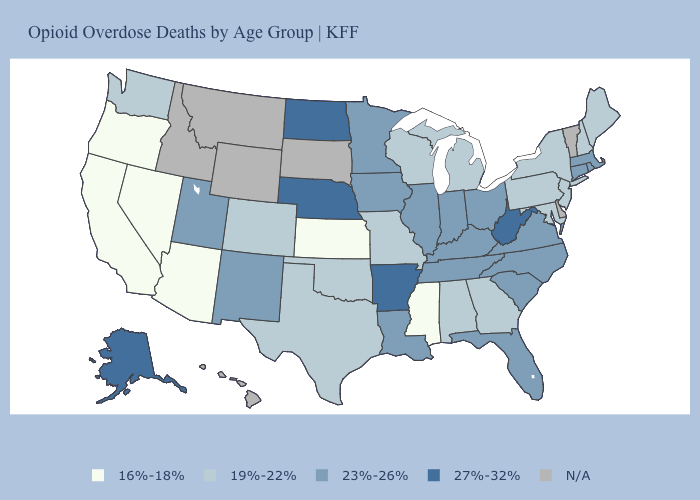Does Minnesota have the lowest value in the MidWest?
Give a very brief answer. No. What is the value of Massachusetts?
Write a very short answer. 23%-26%. What is the value of Minnesota?
Write a very short answer. 23%-26%. Among the states that border South Dakota , does Nebraska have the lowest value?
Write a very short answer. No. What is the highest value in states that border South Dakota?
Be succinct. 27%-32%. What is the value of Florida?
Answer briefly. 23%-26%. Name the states that have a value in the range 27%-32%?
Keep it brief. Alaska, Arkansas, Nebraska, North Dakota, West Virginia. Which states have the lowest value in the South?
Write a very short answer. Mississippi. Which states have the lowest value in the South?
Quick response, please. Mississippi. What is the highest value in the MidWest ?
Give a very brief answer. 27%-32%. What is the value of New Mexico?
Quick response, please. 23%-26%. Name the states that have a value in the range 16%-18%?
Quick response, please. Arizona, California, Kansas, Mississippi, Nevada, Oregon. Among the states that border Nevada , which have the lowest value?
Concise answer only. Arizona, California, Oregon. Does Maine have the highest value in the Northeast?
Short answer required. No. 